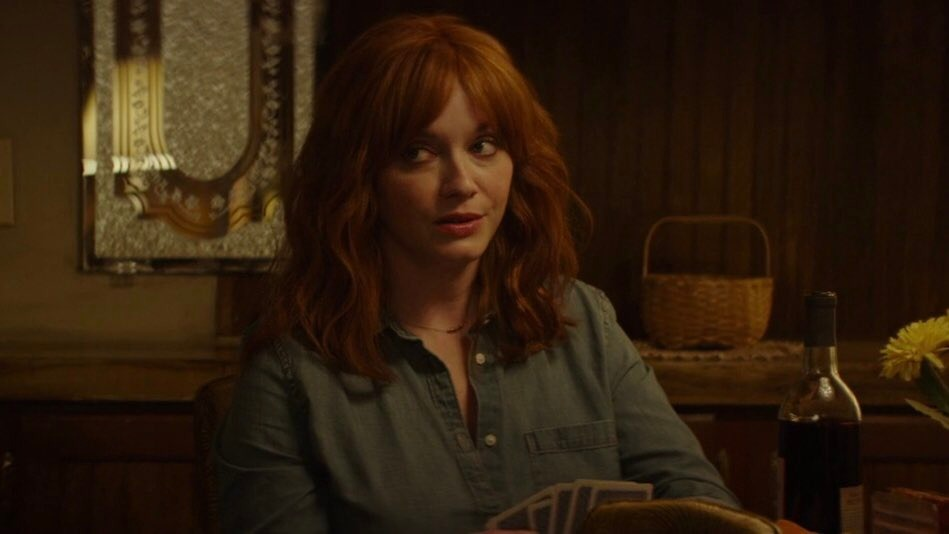What storyline could you imagine for this scene? In this scene, the woman is waiting for a friend to arrive. As she patiently sits at the table, sipping on wine and arranging flowers, a sudden realization prompts a series of questions. Perhaps she has just received unexpected news, and she is trying to piece together the implications. The calm yet introspective setting allows her to navigate her thoughts, exploring the possibilities of what lies ahead. 